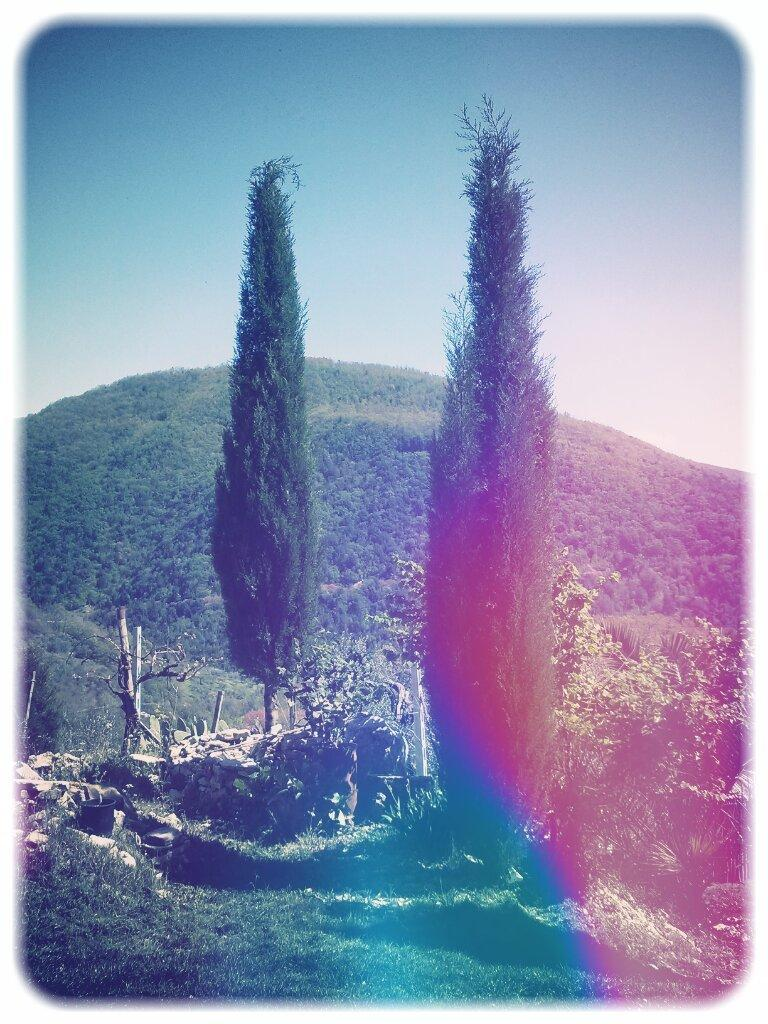What color is the grass in the image? The grass in the image is green. What types of vegetation can be seen in the image? There are plants and trees in the image. What can be seen in the background of the image? There are hills and the sky visible in the background of the image. How many pieces of flesh can be seen in the image? There is no flesh present in the image; it features green grass, plants, trees, hills, and the sky. 